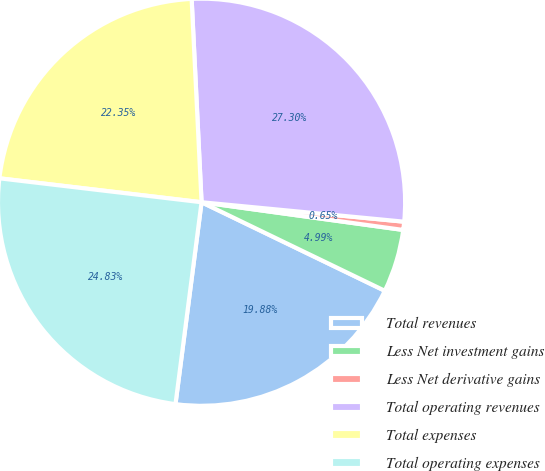<chart> <loc_0><loc_0><loc_500><loc_500><pie_chart><fcel>Total revenues<fcel>Less Net investment gains<fcel>Less Net derivative gains<fcel>Total operating revenues<fcel>Total expenses<fcel>Total operating expenses<nl><fcel>19.88%<fcel>4.99%<fcel>0.65%<fcel>27.3%<fcel>22.35%<fcel>24.83%<nl></chart> 